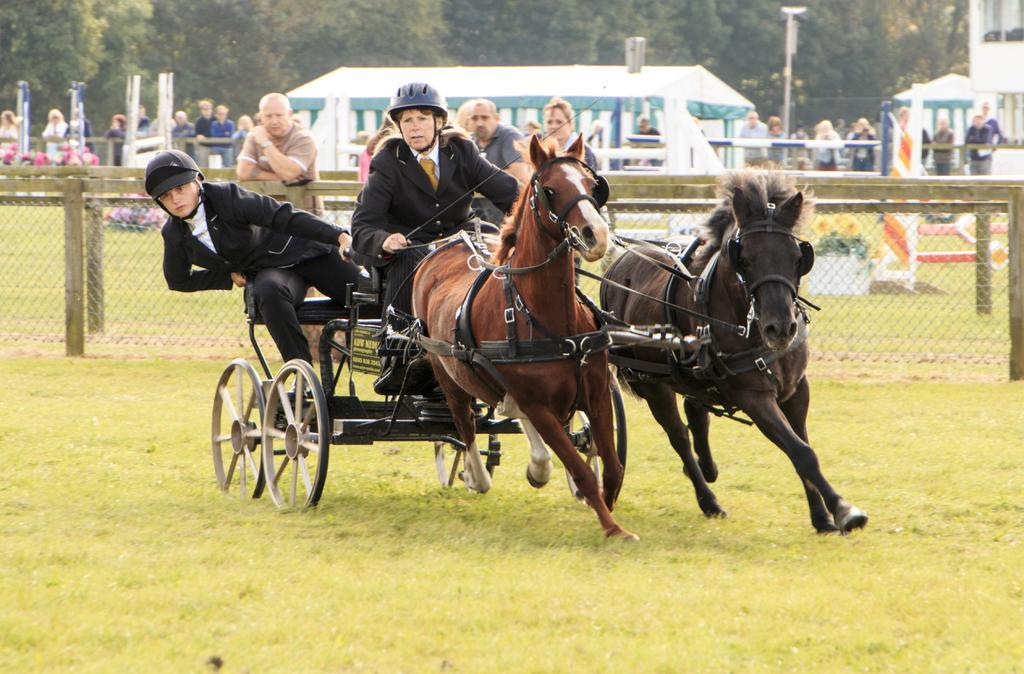Can you describe this image briefly? In this image in the front there's grass on the ground. In the center there is a person riding a horse cart and there is a man sitting in the horse cart. In the background there is a fence and behind the fence there are persons, poles and there are tents and on the right side in the background there is a building and behind the tent, there are trees. 